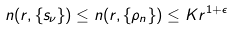<formula> <loc_0><loc_0><loc_500><loc_500>n ( r , \{ s _ { \nu } \} ) \leq n ( r , \{ \rho _ { n } \} ) \leq K r ^ { 1 + \epsilon }</formula> 